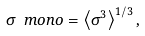<formula> <loc_0><loc_0><loc_500><loc_500>\sigma _ { \ } m o n o = \left \langle \sigma ^ { 3 } \right \rangle ^ { 1 / 3 } ,</formula> 